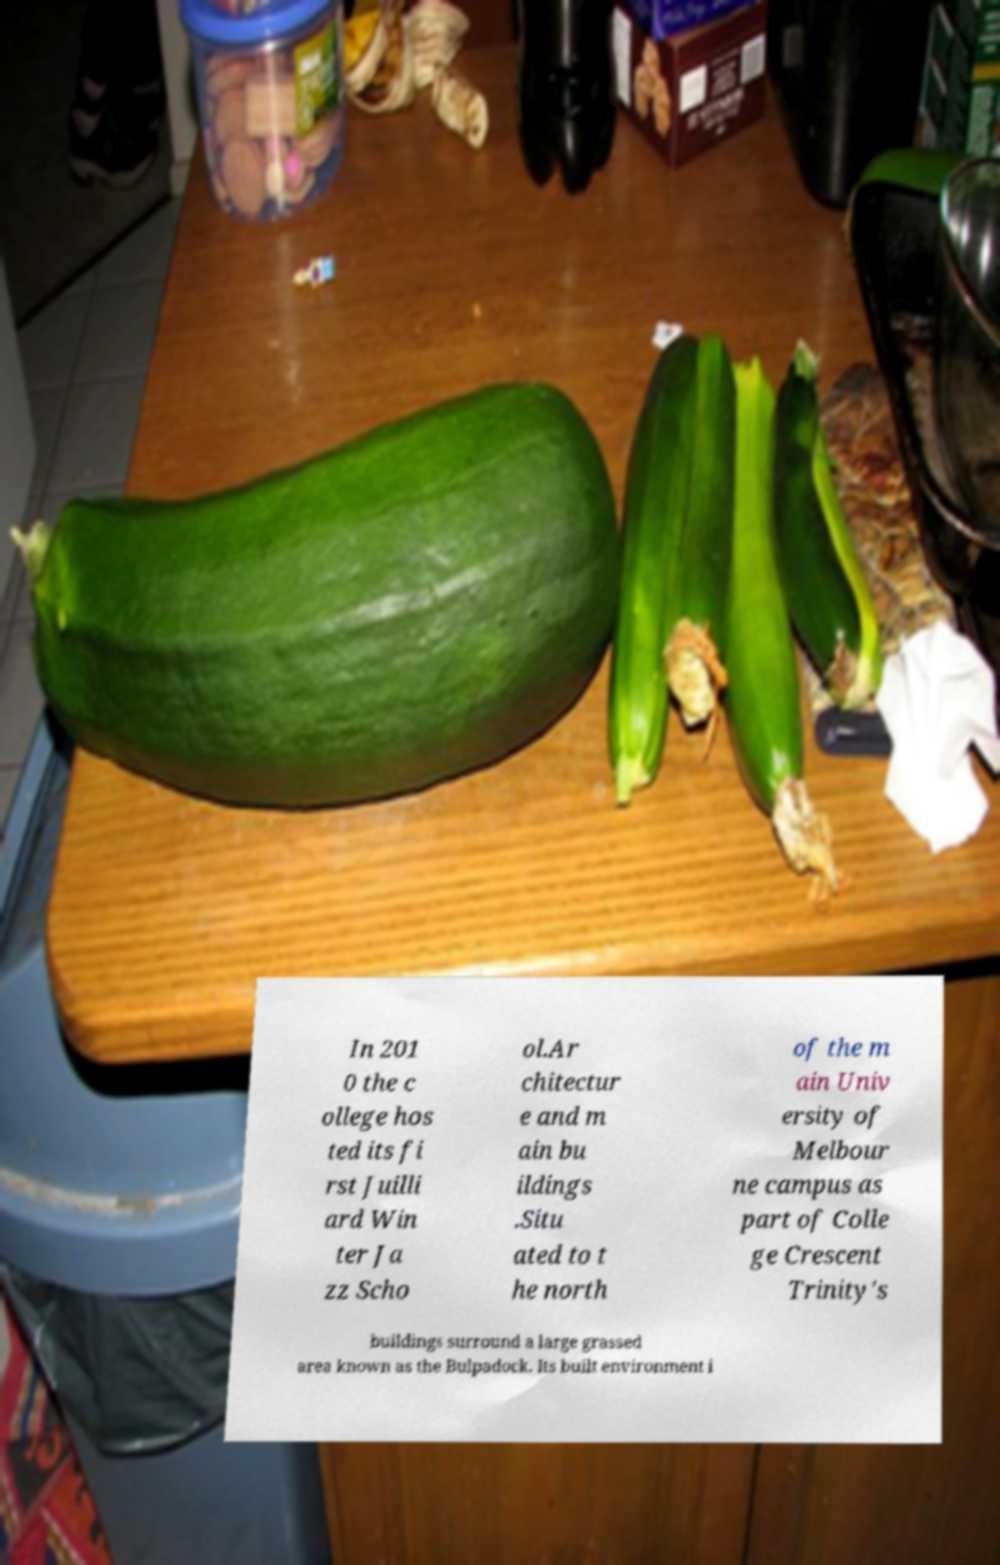Could you assist in decoding the text presented in this image and type it out clearly? In 201 0 the c ollege hos ted its fi rst Juilli ard Win ter Ja zz Scho ol.Ar chitectur e and m ain bu ildings .Situ ated to t he north of the m ain Univ ersity of Melbour ne campus as part of Colle ge Crescent Trinity's buildings surround a large grassed area known as the Bulpadock. Its built environment i 